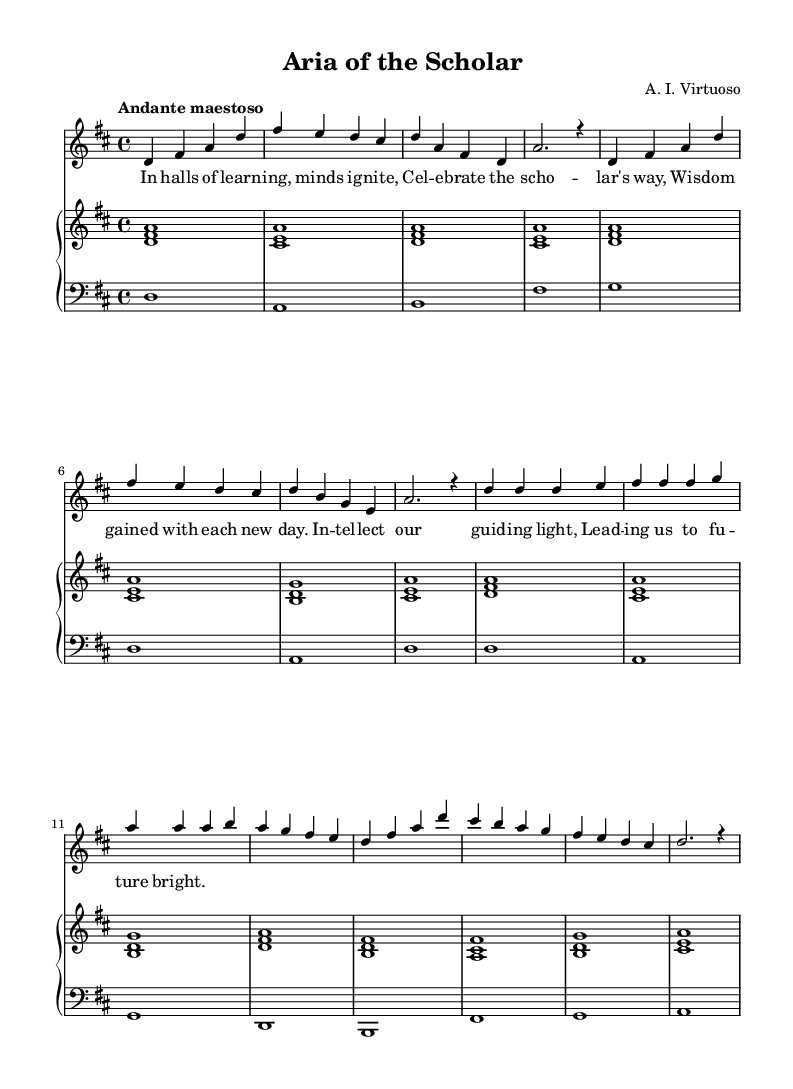What is the key signature of this music? The key signature is indicated by the sharps or flats at the beginning of the staff. This music has two sharps, which corresponds to D major.
Answer: D major What is the time signature of this piece? The time signature is usually located at the beginning of the score, represented as a fraction. In this case, it’s displayed as 4 over 4.
Answer: 4/4 What tempo marking is used in this aria? The tempo marking tells us how fast or slow the piece should be played. Here, it states "Andante maestoso," suggesting a moderately slow, dignified pace.
Answer: Andante maestoso How many measures are in the chorus section? To find the number of measures in the chorus, one must count the measures specifically indicated for that section in the score. The chorus has 8 measures.
Answer: 8 What is the primary theme celebrated in the lyrics? The lyrics highlight intellectual pursuits and the importance of wisdom and learning. They explicitly mention "Celebrate the scholar's way."
Answer: Scholar's way What type of voices does this sheet music seem to be written for? The score includes a melody line that is typically sung, indicating it's for a voice-type, likely a soprano based on the range, with piano accompaniment underneath.
Answer: Soprano What is the lyric corresponding to the introduction of the aria? The lyrics accompanying the introduction melody should be identified directly in the score beneath the melody notes. The text for the introduction is not provided in the excerpt.
Answer: N/A 